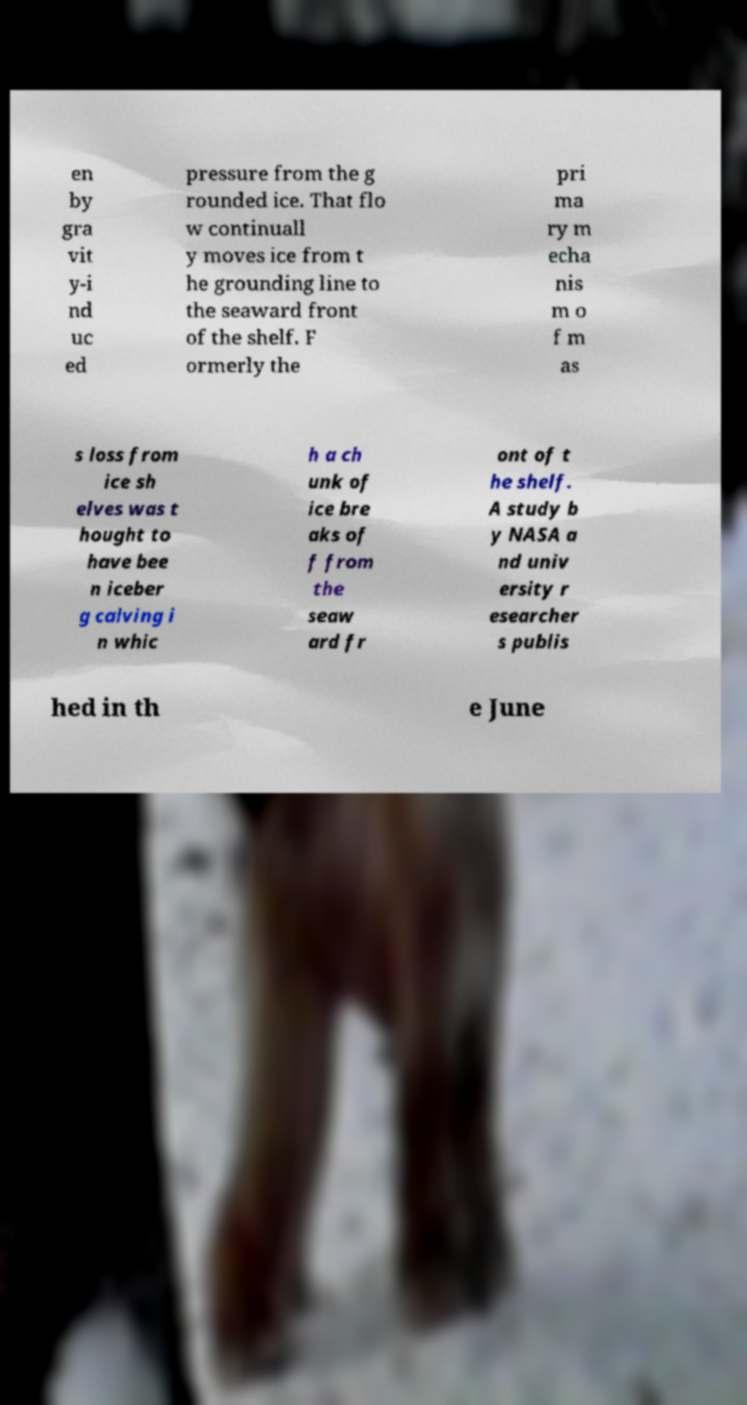Could you extract and type out the text from this image? en by gra vit y-i nd uc ed pressure from the g rounded ice. That flo w continuall y moves ice from t he grounding line to the seaward front of the shelf. F ormerly the pri ma ry m echa nis m o f m as s loss from ice sh elves was t hought to have bee n iceber g calving i n whic h a ch unk of ice bre aks of f from the seaw ard fr ont of t he shelf. A study b y NASA a nd univ ersity r esearcher s publis hed in th e June 